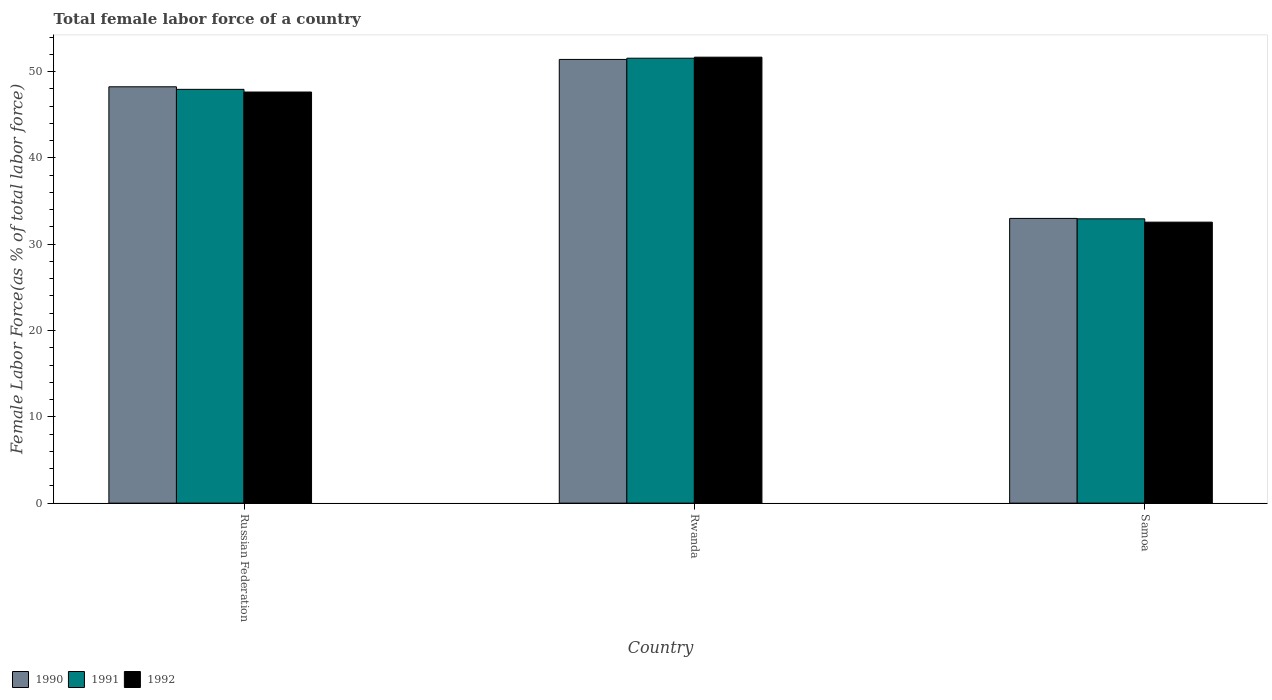How many different coloured bars are there?
Make the answer very short. 3. How many groups of bars are there?
Give a very brief answer. 3. Are the number of bars per tick equal to the number of legend labels?
Your response must be concise. Yes. How many bars are there on the 2nd tick from the left?
Provide a succinct answer. 3. What is the label of the 3rd group of bars from the left?
Your answer should be very brief. Samoa. In how many cases, is the number of bars for a given country not equal to the number of legend labels?
Your response must be concise. 0. What is the percentage of female labor force in 1992 in Samoa?
Ensure brevity in your answer.  32.55. Across all countries, what is the maximum percentage of female labor force in 1990?
Offer a terse response. 51.4. Across all countries, what is the minimum percentage of female labor force in 1991?
Make the answer very short. 32.94. In which country was the percentage of female labor force in 1990 maximum?
Offer a very short reply. Rwanda. In which country was the percentage of female labor force in 1992 minimum?
Give a very brief answer. Samoa. What is the total percentage of female labor force in 1991 in the graph?
Keep it short and to the point. 132.42. What is the difference between the percentage of female labor force in 1990 in Rwanda and that in Samoa?
Give a very brief answer. 18.42. What is the difference between the percentage of female labor force in 1991 in Rwanda and the percentage of female labor force in 1992 in Samoa?
Provide a short and direct response. 18.99. What is the average percentage of female labor force in 1992 per country?
Provide a succinct answer. 43.95. What is the difference between the percentage of female labor force of/in 1992 and percentage of female labor force of/in 1990 in Samoa?
Give a very brief answer. -0.43. What is the ratio of the percentage of female labor force in 1992 in Russian Federation to that in Samoa?
Give a very brief answer. 1.46. What is the difference between the highest and the second highest percentage of female labor force in 1991?
Give a very brief answer. -18.61. What is the difference between the highest and the lowest percentage of female labor force in 1992?
Offer a terse response. 19.11. Is the sum of the percentage of female labor force in 1990 in Russian Federation and Samoa greater than the maximum percentage of female labor force in 1992 across all countries?
Give a very brief answer. Yes. Is it the case that in every country, the sum of the percentage of female labor force in 1991 and percentage of female labor force in 1990 is greater than the percentage of female labor force in 1992?
Offer a terse response. Yes. Are all the bars in the graph horizontal?
Offer a very short reply. No. How many countries are there in the graph?
Your response must be concise. 3. What is the difference between two consecutive major ticks on the Y-axis?
Give a very brief answer. 10. Does the graph contain any zero values?
Ensure brevity in your answer.  No. Does the graph contain grids?
Your response must be concise. No. Where does the legend appear in the graph?
Provide a succinct answer. Bottom left. How are the legend labels stacked?
Provide a succinct answer. Horizontal. What is the title of the graph?
Give a very brief answer. Total female labor force of a country. What is the label or title of the X-axis?
Ensure brevity in your answer.  Country. What is the label or title of the Y-axis?
Offer a terse response. Female Labor Force(as % of total labor force). What is the Female Labor Force(as % of total labor force) in 1990 in Russian Federation?
Offer a very short reply. 48.24. What is the Female Labor Force(as % of total labor force) in 1991 in Russian Federation?
Keep it short and to the point. 47.94. What is the Female Labor Force(as % of total labor force) of 1992 in Russian Federation?
Provide a short and direct response. 47.63. What is the Female Labor Force(as % of total labor force) in 1990 in Rwanda?
Offer a very short reply. 51.4. What is the Female Labor Force(as % of total labor force) of 1991 in Rwanda?
Keep it short and to the point. 51.55. What is the Female Labor Force(as % of total labor force) of 1992 in Rwanda?
Your response must be concise. 51.67. What is the Female Labor Force(as % of total labor force) in 1990 in Samoa?
Ensure brevity in your answer.  32.99. What is the Female Labor Force(as % of total labor force) in 1991 in Samoa?
Ensure brevity in your answer.  32.94. What is the Female Labor Force(as % of total labor force) of 1992 in Samoa?
Your answer should be very brief. 32.55. Across all countries, what is the maximum Female Labor Force(as % of total labor force) of 1990?
Your response must be concise. 51.4. Across all countries, what is the maximum Female Labor Force(as % of total labor force) in 1991?
Your response must be concise. 51.55. Across all countries, what is the maximum Female Labor Force(as % of total labor force) of 1992?
Keep it short and to the point. 51.67. Across all countries, what is the minimum Female Labor Force(as % of total labor force) of 1990?
Your answer should be compact. 32.99. Across all countries, what is the minimum Female Labor Force(as % of total labor force) in 1991?
Your answer should be very brief. 32.94. Across all countries, what is the minimum Female Labor Force(as % of total labor force) in 1992?
Offer a very short reply. 32.55. What is the total Female Labor Force(as % of total labor force) in 1990 in the graph?
Ensure brevity in your answer.  132.63. What is the total Female Labor Force(as % of total labor force) in 1991 in the graph?
Give a very brief answer. 132.42. What is the total Female Labor Force(as % of total labor force) in 1992 in the graph?
Give a very brief answer. 131.85. What is the difference between the Female Labor Force(as % of total labor force) in 1990 in Russian Federation and that in Rwanda?
Keep it short and to the point. -3.17. What is the difference between the Female Labor Force(as % of total labor force) of 1991 in Russian Federation and that in Rwanda?
Your answer should be very brief. -3.61. What is the difference between the Female Labor Force(as % of total labor force) in 1992 in Russian Federation and that in Rwanda?
Your answer should be very brief. -4.04. What is the difference between the Female Labor Force(as % of total labor force) of 1990 in Russian Federation and that in Samoa?
Your response must be concise. 15.25. What is the difference between the Female Labor Force(as % of total labor force) of 1991 in Russian Federation and that in Samoa?
Give a very brief answer. 15. What is the difference between the Female Labor Force(as % of total labor force) in 1992 in Russian Federation and that in Samoa?
Provide a short and direct response. 15.07. What is the difference between the Female Labor Force(as % of total labor force) of 1990 in Rwanda and that in Samoa?
Give a very brief answer. 18.42. What is the difference between the Female Labor Force(as % of total labor force) in 1991 in Rwanda and that in Samoa?
Keep it short and to the point. 18.61. What is the difference between the Female Labor Force(as % of total labor force) in 1992 in Rwanda and that in Samoa?
Your answer should be very brief. 19.11. What is the difference between the Female Labor Force(as % of total labor force) of 1990 in Russian Federation and the Female Labor Force(as % of total labor force) of 1991 in Rwanda?
Provide a short and direct response. -3.31. What is the difference between the Female Labor Force(as % of total labor force) in 1990 in Russian Federation and the Female Labor Force(as % of total labor force) in 1992 in Rwanda?
Ensure brevity in your answer.  -3.43. What is the difference between the Female Labor Force(as % of total labor force) in 1991 in Russian Federation and the Female Labor Force(as % of total labor force) in 1992 in Rwanda?
Give a very brief answer. -3.73. What is the difference between the Female Labor Force(as % of total labor force) in 1990 in Russian Federation and the Female Labor Force(as % of total labor force) in 1991 in Samoa?
Your answer should be compact. 15.3. What is the difference between the Female Labor Force(as % of total labor force) of 1990 in Russian Federation and the Female Labor Force(as % of total labor force) of 1992 in Samoa?
Offer a very short reply. 15.68. What is the difference between the Female Labor Force(as % of total labor force) in 1991 in Russian Federation and the Female Labor Force(as % of total labor force) in 1992 in Samoa?
Provide a short and direct response. 15.38. What is the difference between the Female Labor Force(as % of total labor force) of 1990 in Rwanda and the Female Labor Force(as % of total labor force) of 1991 in Samoa?
Provide a short and direct response. 18.47. What is the difference between the Female Labor Force(as % of total labor force) in 1990 in Rwanda and the Female Labor Force(as % of total labor force) in 1992 in Samoa?
Offer a very short reply. 18.85. What is the difference between the Female Labor Force(as % of total labor force) of 1991 in Rwanda and the Female Labor Force(as % of total labor force) of 1992 in Samoa?
Your answer should be compact. 18.99. What is the average Female Labor Force(as % of total labor force) of 1990 per country?
Provide a short and direct response. 44.21. What is the average Female Labor Force(as % of total labor force) of 1991 per country?
Keep it short and to the point. 44.14. What is the average Female Labor Force(as % of total labor force) in 1992 per country?
Your answer should be very brief. 43.95. What is the difference between the Female Labor Force(as % of total labor force) in 1990 and Female Labor Force(as % of total labor force) in 1991 in Russian Federation?
Your response must be concise. 0.3. What is the difference between the Female Labor Force(as % of total labor force) of 1990 and Female Labor Force(as % of total labor force) of 1992 in Russian Federation?
Ensure brevity in your answer.  0.61. What is the difference between the Female Labor Force(as % of total labor force) of 1991 and Female Labor Force(as % of total labor force) of 1992 in Russian Federation?
Provide a succinct answer. 0.31. What is the difference between the Female Labor Force(as % of total labor force) of 1990 and Female Labor Force(as % of total labor force) of 1991 in Rwanda?
Provide a short and direct response. -0.14. What is the difference between the Female Labor Force(as % of total labor force) of 1990 and Female Labor Force(as % of total labor force) of 1992 in Rwanda?
Offer a very short reply. -0.26. What is the difference between the Female Labor Force(as % of total labor force) of 1991 and Female Labor Force(as % of total labor force) of 1992 in Rwanda?
Give a very brief answer. -0.12. What is the difference between the Female Labor Force(as % of total labor force) in 1990 and Female Labor Force(as % of total labor force) in 1991 in Samoa?
Give a very brief answer. 0.05. What is the difference between the Female Labor Force(as % of total labor force) of 1990 and Female Labor Force(as % of total labor force) of 1992 in Samoa?
Keep it short and to the point. 0.43. What is the difference between the Female Labor Force(as % of total labor force) in 1991 and Female Labor Force(as % of total labor force) in 1992 in Samoa?
Provide a succinct answer. 0.38. What is the ratio of the Female Labor Force(as % of total labor force) of 1990 in Russian Federation to that in Rwanda?
Offer a terse response. 0.94. What is the ratio of the Female Labor Force(as % of total labor force) in 1992 in Russian Federation to that in Rwanda?
Make the answer very short. 0.92. What is the ratio of the Female Labor Force(as % of total labor force) in 1990 in Russian Federation to that in Samoa?
Provide a succinct answer. 1.46. What is the ratio of the Female Labor Force(as % of total labor force) of 1991 in Russian Federation to that in Samoa?
Your answer should be very brief. 1.46. What is the ratio of the Female Labor Force(as % of total labor force) of 1992 in Russian Federation to that in Samoa?
Provide a succinct answer. 1.46. What is the ratio of the Female Labor Force(as % of total labor force) of 1990 in Rwanda to that in Samoa?
Your response must be concise. 1.56. What is the ratio of the Female Labor Force(as % of total labor force) of 1991 in Rwanda to that in Samoa?
Keep it short and to the point. 1.56. What is the ratio of the Female Labor Force(as % of total labor force) of 1992 in Rwanda to that in Samoa?
Your response must be concise. 1.59. What is the difference between the highest and the second highest Female Labor Force(as % of total labor force) in 1990?
Offer a very short reply. 3.17. What is the difference between the highest and the second highest Female Labor Force(as % of total labor force) of 1991?
Offer a terse response. 3.61. What is the difference between the highest and the second highest Female Labor Force(as % of total labor force) in 1992?
Provide a succinct answer. 4.04. What is the difference between the highest and the lowest Female Labor Force(as % of total labor force) of 1990?
Your answer should be very brief. 18.42. What is the difference between the highest and the lowest Female Labor Force(as % of total labor force) of 1991?
Give a very brief answer. 18.61. What is the difference between the highest and the lowest Female Labor Force(as % of total labor force) in 1992?
Offer a terse response. 19.11. 